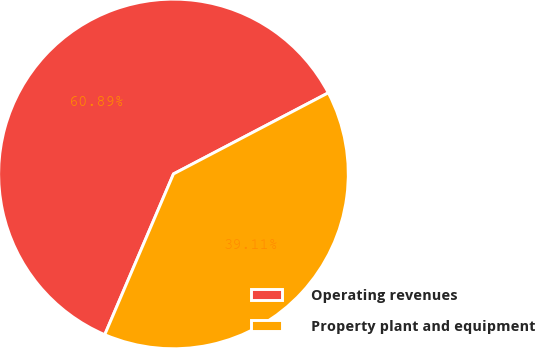Convert chart. <chart><loc_0><loc_0><loc_500><loc_500><pie_chart><fcel>Operating revenues<fcel>Property plant and equipment<nl><fcel>60.89%<fcel>39.11%<nl></chart> 